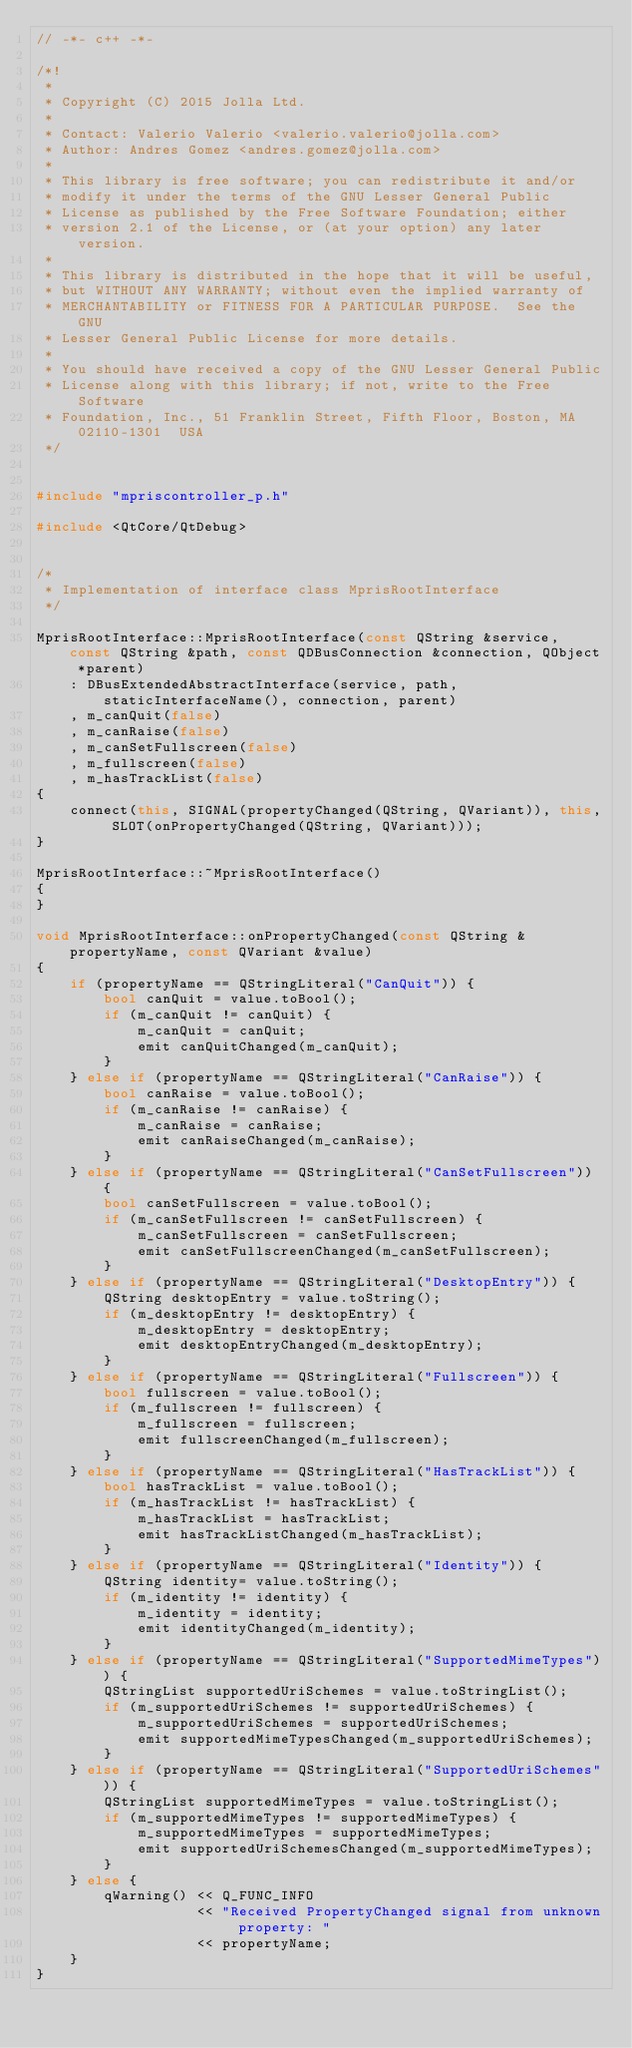Convert code to text. <code><loc_0><loc_0><loc_500><loc_500><_C++_>// -*- c++ -*-

/*!
 *
 * Copyright (C) 2015 Jolla Ltd.
 *
 * Contact: Valerio Valerio <valerio.valerio@jolla.com>
 * Author: Andres Gomez <andres.gomez@jolla.com>
 *
 * This library is free software; you can redistribute it and/or
 * modify it under the terms of the GNU Lesser General Public
 * License as published by the Free Software Foundation; either
 * version 2.1 of the License, or (at your option) any later version.
 *
 * This library is distributed in the hope that it will be useful,
 * but WITHOUT ANY WARRANTY; without even the implied warranty of
 * MERCHANTABILITY or FITNESS FOR A PARTICULAR PURPOSE.  See the GNU
 * Lesser General Public License for more details.
 *
 * You should have received a copy of the GNU Lesser General Public
 * License along with this library; if not, write to the Free Software
 * Foundation, Inc., 51 Franklin Street, Fifth Floor, Boston, MA  02110-1301  USA
 */


#include "mpriscontroller_p.h"

#include <QtCore/QtDebug>


/*
 * Implementation of interface class MprisRootInterface
 */

MprisRootInterface::MprisRootInterface(const QString &service, const QString &path, const QDBusConnection &connection, QObject *parent)
    : DBusExtendedAbstractInterface(service, path, staticInterfaceName(), connection, parent)
    , m_canQuit(false)
    , m_canRaise(false)
    , m_canSetFullscreen(false)
    , m_fullscreen(false)
    , m_hasTrackList(false)
{
    connect(this, SIGNAL(propertyChanged(QString, QVariant)), this, SLOT(onPropertyChanged(QString, QVariant)));
}

MprisRootInterface::~MprisRootInterface()
{
}

void MprisRootInterface::onPropertyChanged(const QString &propertyName, const QVariant &value)
{
    if (propertyName == QStringLiteral("CanQuit")) {
        bool canQuit = value.toBool();
        if (m_canQuit != canQuit) {
            m_canQuit = canQuit;
            emit canQuitChanged(m_canQuit);
        }
    } else if (propertyName == QStringLiteral("CanRaise")) {
        bool canRaise = value.toBool();
        if (m_canRaise != canRaise) {
            m_canRaise = canRaise;
            emit canRaiseChanged(m_canRaise);
        }
    } else if (propertyName == QStringLiteral("CanSetFullscreen")) {
        bool canSetFullscreen = value.toBool();
        if (m_canSetFullscreen != canSetFullscreen) {
            m_canSetFullscreen = canSetFullscreen;
            emit canSetFullscreenChanged(m_canSetFullscreen);
        }
    } else if (propertyName == QStringLiteral("DesktopEntry")) {
        QString desktopEntry = value.toString();
        if (m_desktopEntry != desktopEntry) {
            m_desktopEntry = desktopEntry;
            emit desktopEntryChanged(m_desktopEntry);
        }
    } else if (propertyName == QStringLiteral("Fullscreen")) {
        bool fullscreen = value.toBool();
        if (m_fullscreen != fullscreen) {
            m_fullscreen = fullscreen;
            emit fullscreenChanged(m_fullscreen);
        }
    } else if (propertyName == QStringLiteral("HasTrackList")) {
        bool hasTrackList = value.toBool();
        if (m_hasTrackList != hasTrackList) {
            m_hasTrackList = hasTrackList;
            emit hasTrackListChanged(m_hasTrackList);
        }
    } else if (propertyName == QStringLiteral("Identity")) {
        QString identity= value.toString();
        if (m_identity != identity) {
            m_identity = identity;
            emit identityChanged(m_identity);
        }
    } else if (propertyName == QStringLiteral("SupportedMimeTypes")) {
        QStringList supportedUriSchemes = value.toStringList();
        if (m_supportedUriSchemes != supportedUriSchemes) {
            m_supportedUriSchemes = supportedUriSchemes;
            emit supportedMimeTypesChanged(m_supportedUriSchemes);
        }
    } else if (propertyName == QStringLiteral("SupportedUriSchemes")) {
        QStringList supportedMimeTypes = value.toStringList();
        if (m_supportedMimeTypes != supportedMimeTypes) {
            m_supportedMimeTypes = supportedMimeTypes;
            emit supportedUriSchemesChanged(m_supportedMimeTypes);
        }
    } else {
        qWarning() << Q_FUNC_INFO
                   << "Received PropertyChanged signal from unknown property: "
                   << propertyName;
    }
}

</code> 